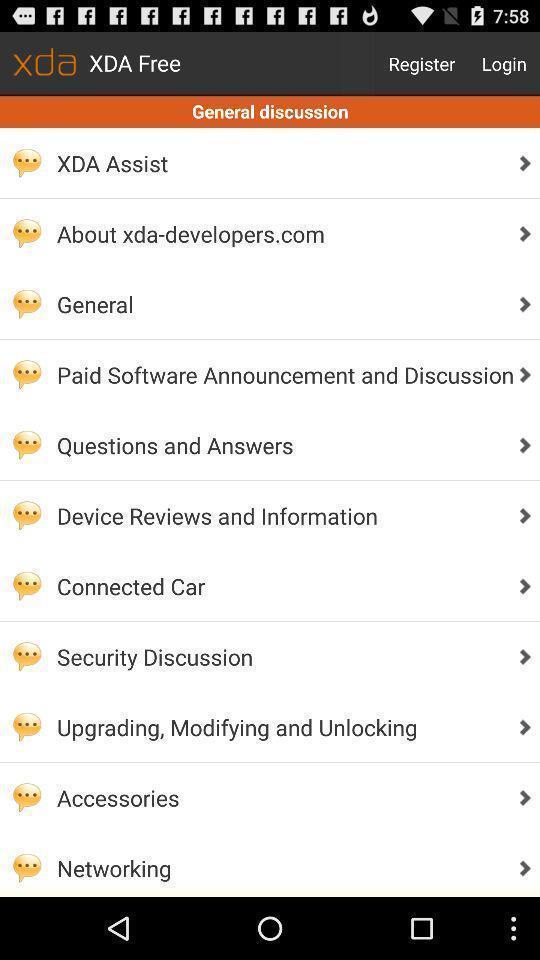What is the overall content of this screenshot? Page showing general discussion. 